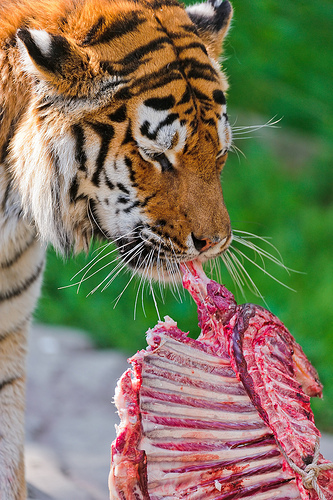<image>
Can you confirm if the tiger is behind the meat? No. The tiger is not behind the meat. From this viewpoint, the tiger appears to be positioned elsewhere in the scene. Is there a tiger above the meat? No. The tiger is not positioned above the meat. The vertical arrangement shows a different relationship. Is there a tiger above the meal? No. The tiger is not positioned above the meal. The vertical arrangement shows a different relationship. 